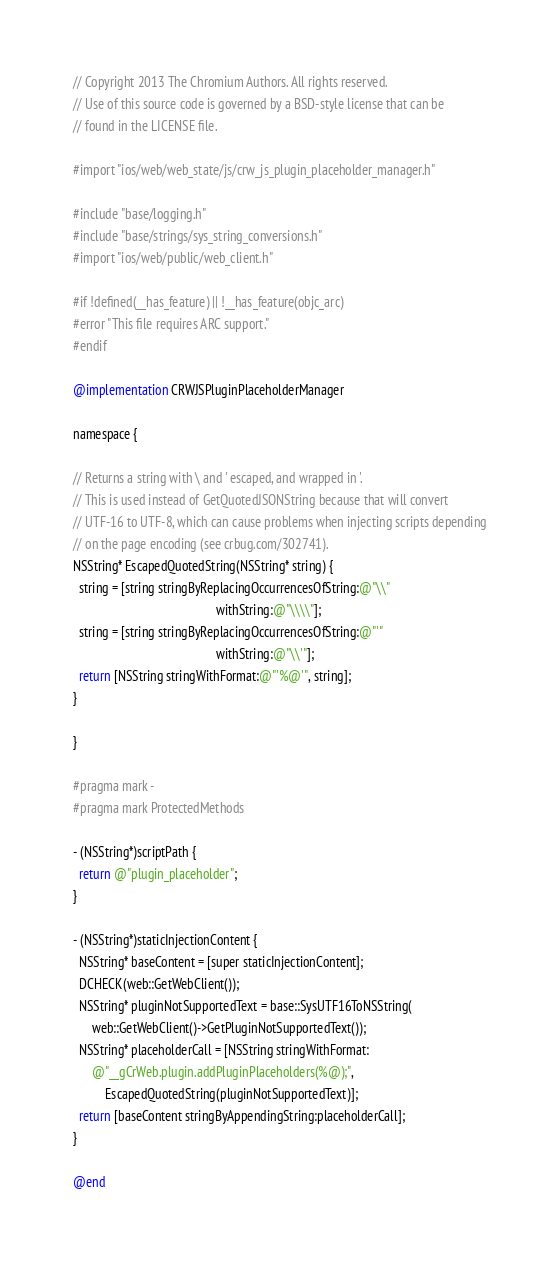<code> <loc_0><loc_0><loc_500><loc_500><_ObjectiveC_>// Copyright 2013 The Chromium Authors. All rights reserved.
// Use of this source code is governed by a BSD-style license that can be
// found in the LICENSE file.

#import "ios/web/web_state/js/crw_js_plugin_placeholder_manager.h"

#include "base/logging.h"
#include "base/strings/sys_string_conversions.h"
#import "ios/web/public/web_client.h"

#if !defined(__has_feature) || !__has_feature(objc_arc)
#error "This file requires ARC support."
#endif

@implementation CRWJSPluginPlaceholderManager

namespace {

// Returns a string with \ and ' escaped, and wrapped in '.
// This is used instead of GetQuotedJSONString because that will convert
// UTF-16 to UTF-8, which can cause problems when injecting scripts depending
// on the page encoding (see crbug.com/302741).
NSString* EscapedQuotedString(NSString* string) {
  string = [string stringByReplacingOccurrencesOfString:@"\\"
                                             withString:@"\\\\"];
  string = [string stringByReplacingOccurrencesOfString:@"'"
                                             withString:@"\\'"];
  return [NSString stringWithFormat:@"'%@'", string];
}

}

#pragma mark -
#pragma mark ProtectedMethods

- (NSString*)scriptPath {
  return @"plugin_placeholder";
}

- (NSString*)staticInjectionContent {
  NSString* baseContent = [super staticInjectionContent];
  DCHECK(web::GetWebClient());
  NSString* pluginNotSupportedText = base::SysUTF16ToNSString(
      web::GetWebClient()->GetPluginNotSupportedText());
  NSString* placeholderCall = [NSString stringWithFormat:
      @"__gCrWeb.plugin.addPluginPlaceholders(%@);",
          EscapedQuotedString(pluginNotSupportedText)];
  return [baseContent stringByAppendingString:placeholderCall];
}

@end
</code> 